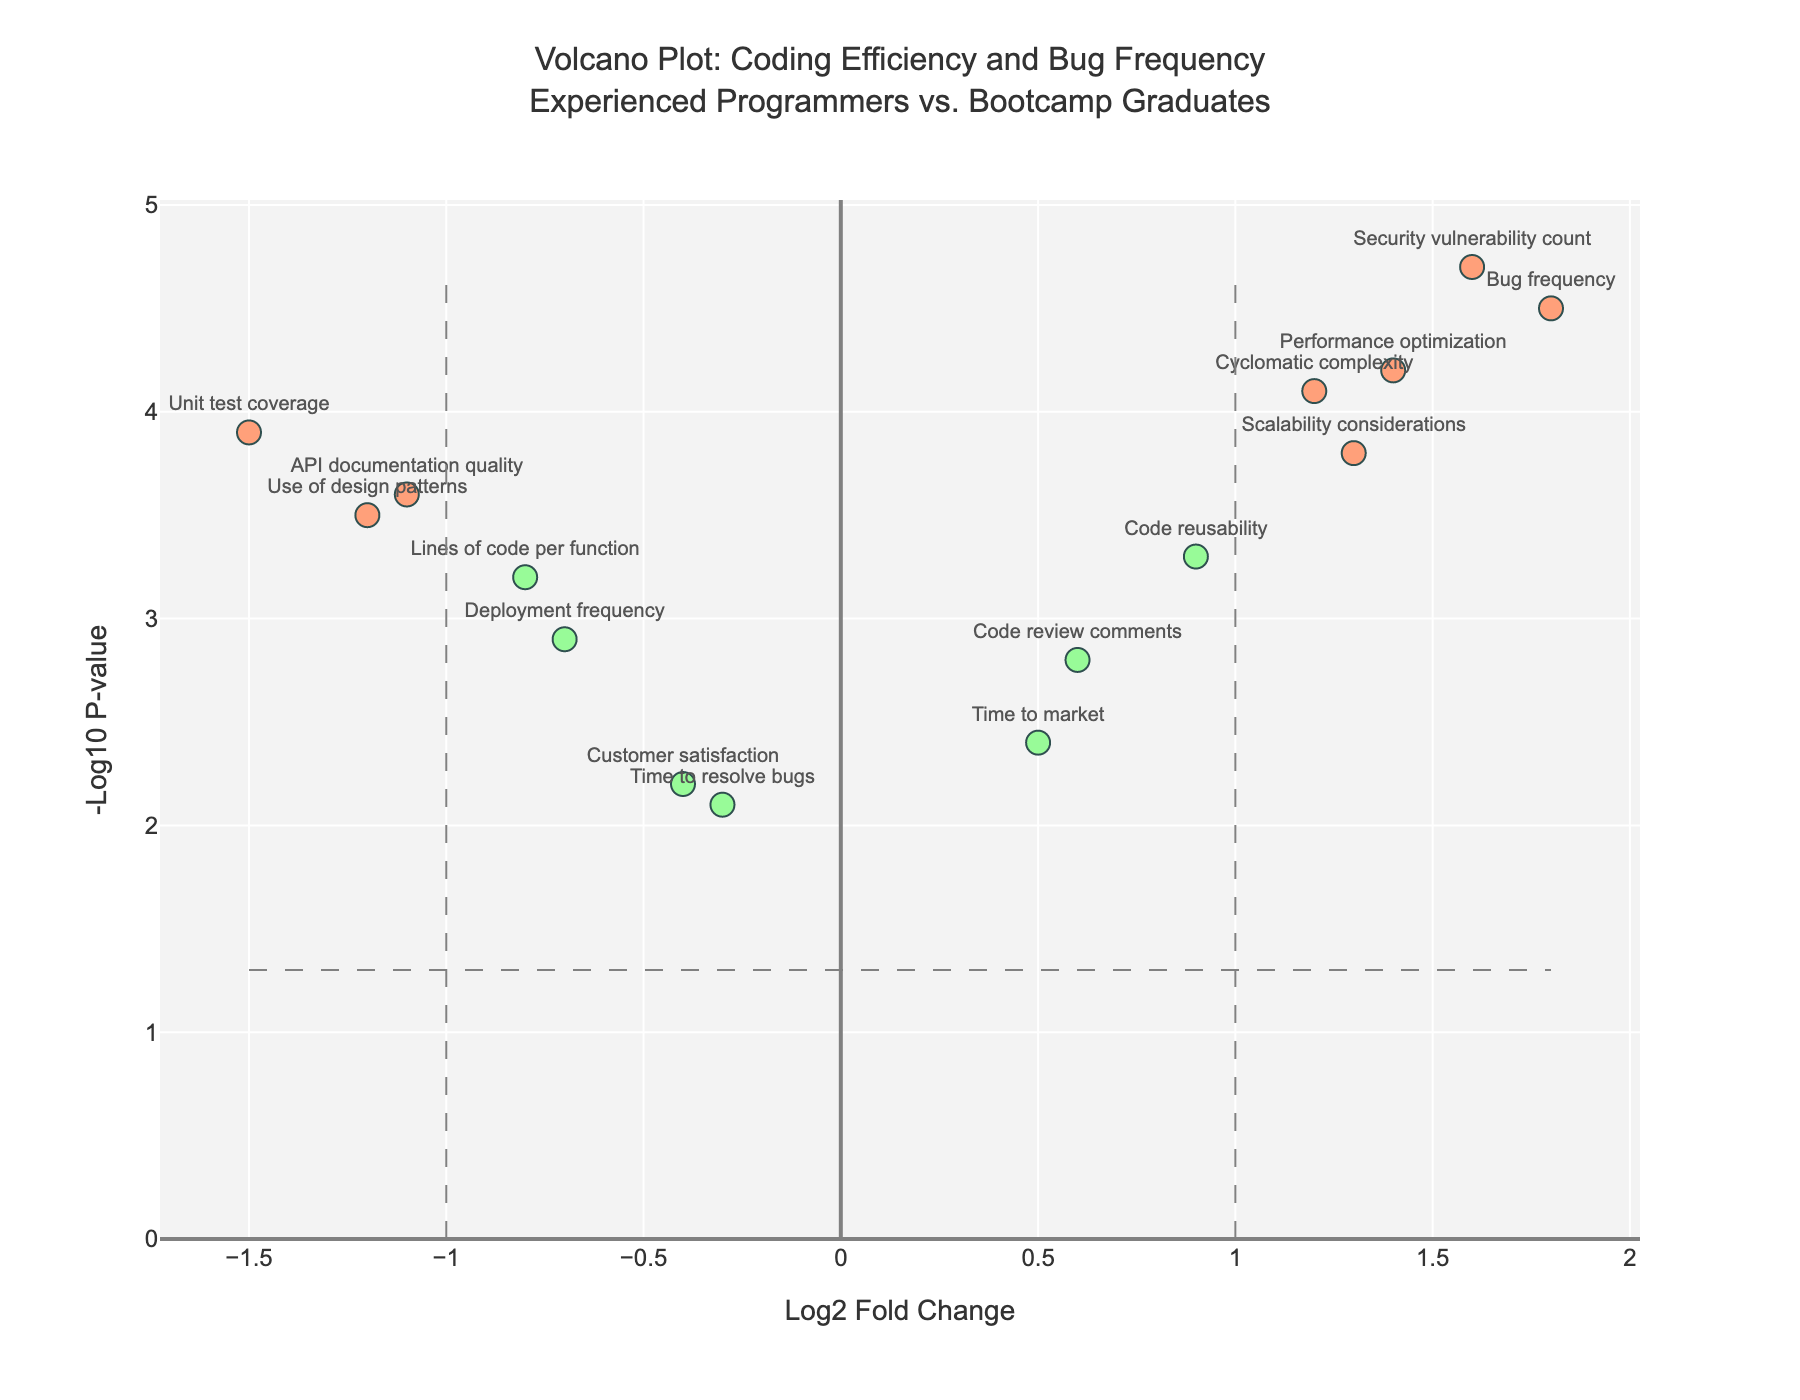What is the title of the figure? The title of the figure is usually located at the top of the plot. In this case, it reads "Volcano Plot: Coding Efficiency and Bug Frequency<br>Experienced Programmers vs. Bootcamp Graduates"
Answer: Volcano Plot: Coding Efficiency and Bug Frequency<br>Experienced Programmers vs. Bootcamp Graduates Which feature has the highest -log10(p-value)? To determine this, look for the data point that reaches the highest value on the y-axis, which represents the -log10(p-value). In the plot, this is "Security vulnerability count."
Answer: Security vulnerability count Which feature exhibits the least significant p-value, but still maintains a log2 fold change greater than 1? Identify data points with log2 fold change greater than 1 and find the one with the smallest value on the y-axis (least significant p-value). This feature is "Cyclomatic complexity."
Answer: Cyclomatic complexity What color represents features with both significant log2 fold changes and p-values? The color coding uses three different shades. Significant changes in both log2FC and p-value are colored distinctly. According to the code, these points are colored with the first color in the list (likely a red or orange shade).
Answer: red or orange How many features are labeled with their names on the plot? By inspecting the visual markers, the features labeled with their names are counted directly from the plot.
Answer: 15 Which feature has the most profound negative log2 fold change? To answer this, look for the data point farthest to the left on the x-axis, which illustrates the largest negative log2 fold change. This feature is "Unit test coverage."
Answer: Unit test coverage Which feature has a moderate log2 fold change and a relatively low p-value? Look for features with log2 fold change near zero on the x-axis and a low position on the y-axis. "Time to resolve bugs" is one such feature.
Answer: Time to resolve bugs Which features indicate experienced programmers performed better according to the plot? Features with negative log2FC values (left of center) suggest experienced programmers performed better. These include: "Lines of code per function," "Unit test coverage," "API documentation quality," "Deployment frequency," "Time to market," "Customer satisfaction," "Use of design patterns."
Answer: Various features are listed 